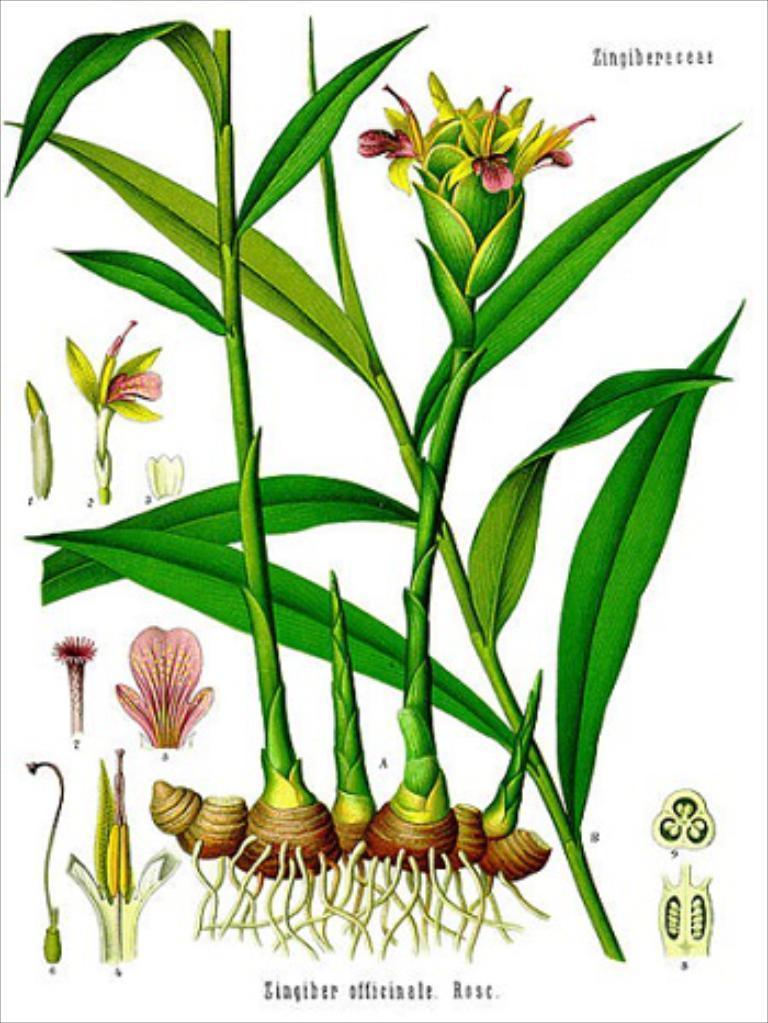Please provide a concise description of this image. In this image I can see the digital art of few plants which are green in color. I can see few flowers which are pink in color and I can see the white background. 